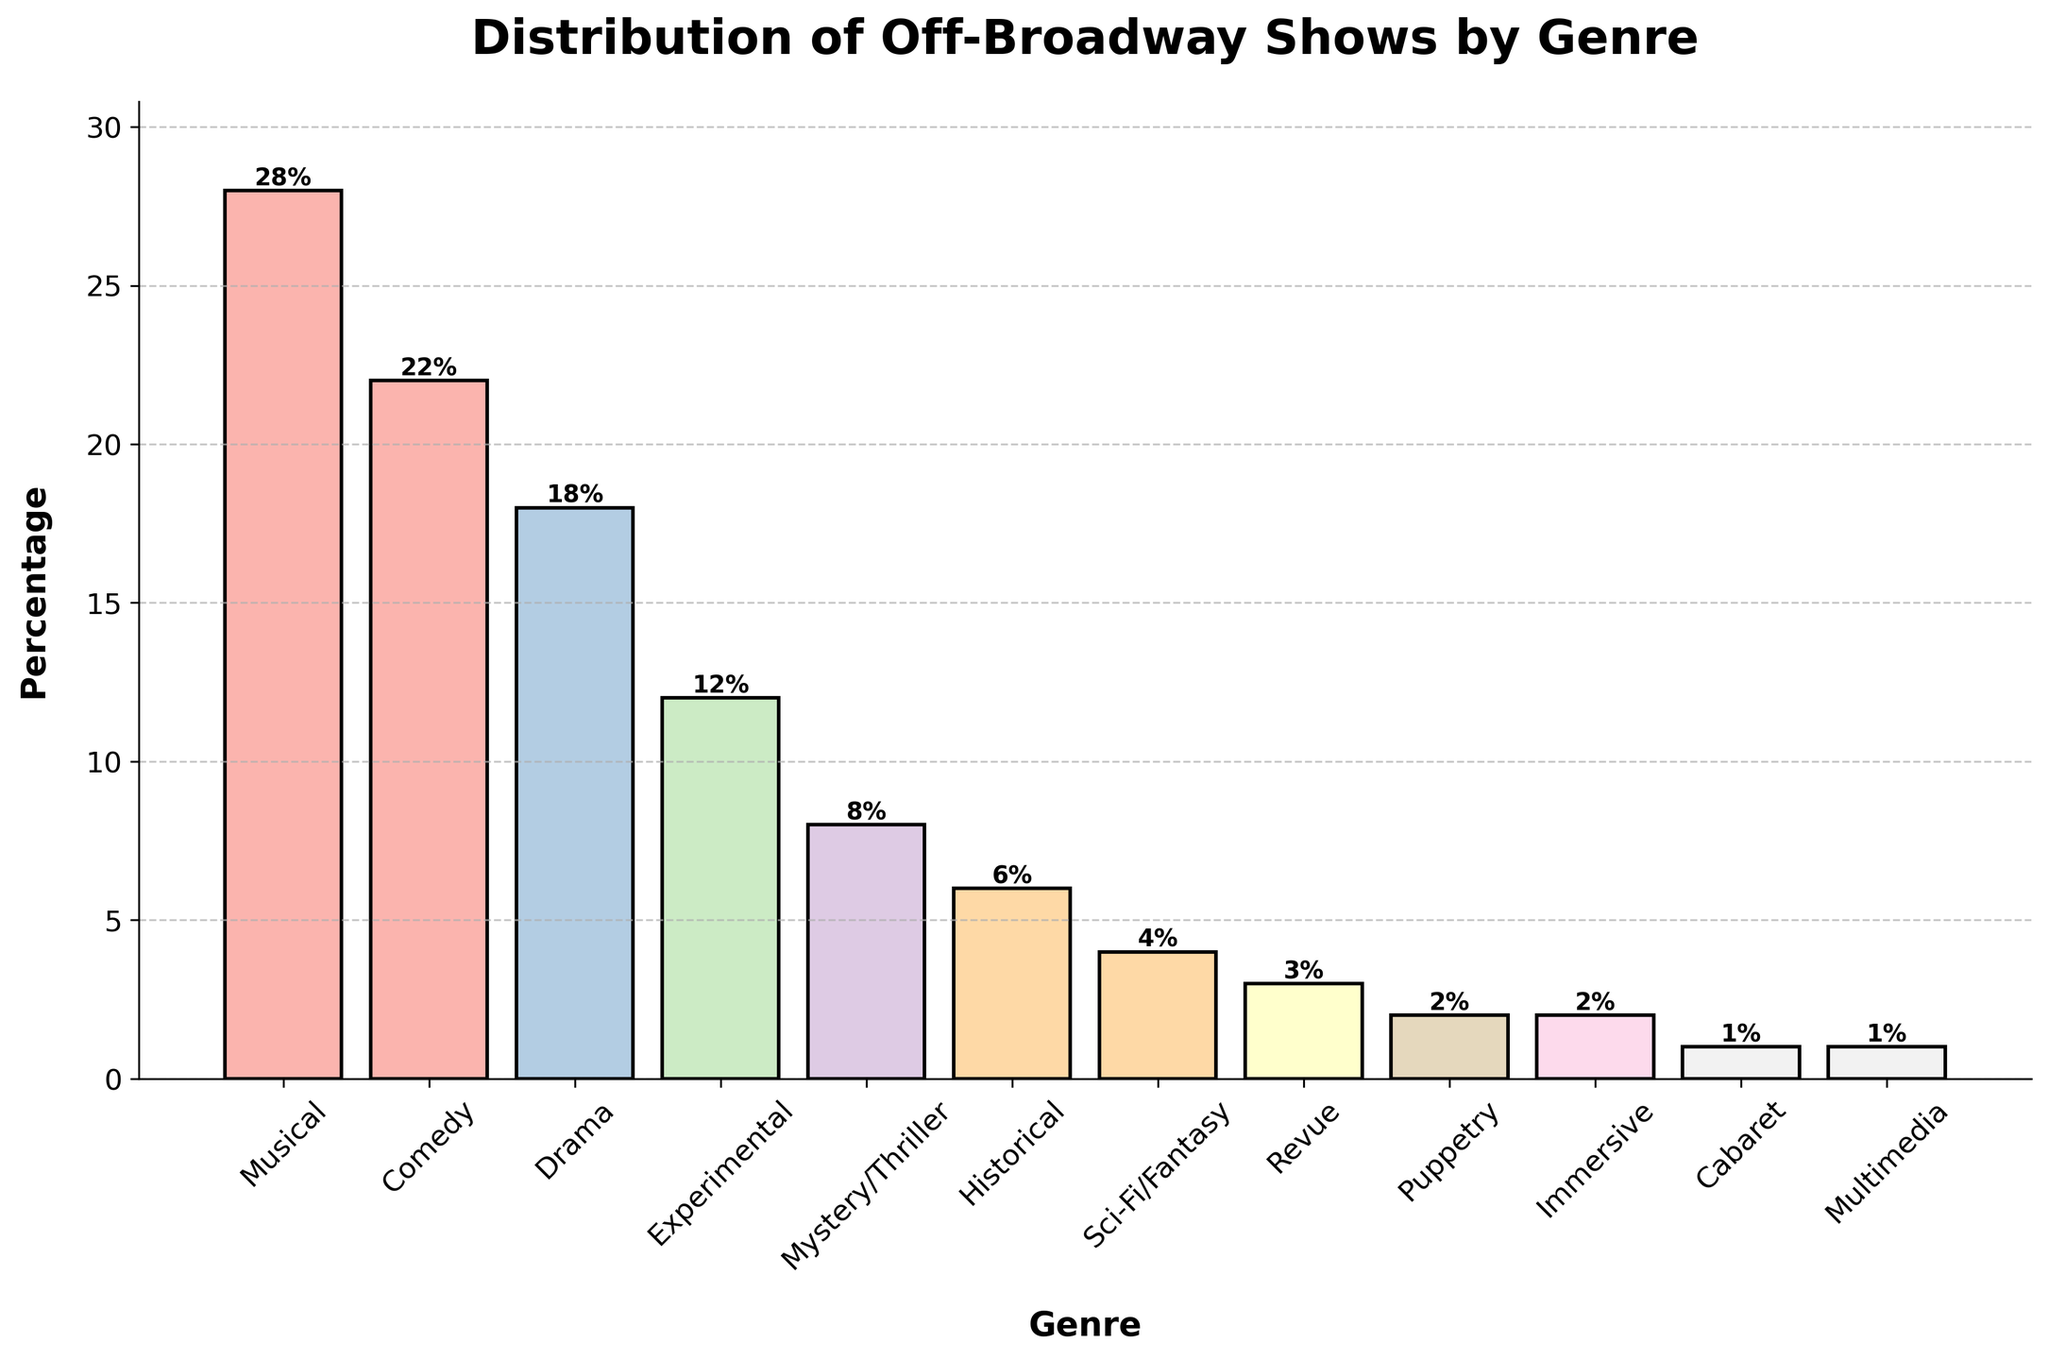What is the most common genre of off-Broadway shows in the last 5 years? By looking at the height of the bars, the tallest bar represents the genre with the highest percentage. The bar labeled "Musical" is the tallest.
Answer: Musical Which genre has a higher percentage, Comedy or Drama? By comparing the heights of the bars labeled "Comedy" and "Drama," the Comedy bar is taller.
Answer: Comedy What is the total percentage of off-Broadway shows that are either Experimental, Mystery/Thriller, or Historical? Summing the percentages of Experimental (12%), Mystery/Thriller (8%), and Historical (6%): 12% + 8% + 6% = 26%
Answer: 26% Is the percentage of Musical shows more than double the percentage of Comedy shows? The percentage of Musical shows is 28%, and the percentage of Comedy shows is 22%. Doubling the percentage of Comedy shows gives 22% * 2 = 44%. Since 28% < 44%, Musical shows are not more than double the percentage of Comedy shows.
Answer: No What is the second least common genre of off-Broadway shows? By observing the heights of the bars, the second smallest bar corresponds to the genre "Immersive" with 2%.
Answer: Immersive How does the percentage of Sci-Fi/Fantasy shows compare to the percentage of Revue shows? By examining the heights of the corresponding bars, Sci-Fi/Fantasy has a percentage of 4%, while Revue has a percentage of 3%. Sci-Fi/Fantasy has a higher percentage than Revue.
Answer: Sci-Fi/Fantasy What is the combined percentage of the three least common genres? Adding the percentages of Puppetry (2%), Immersive (2%), and Cabaret/Multimedia (both 1%): 2% + 2% + 1% + 1% = 6%
Answer: 6% Which genre is represented by the bar colored in the lightest shade? The lightest shade corresponds to the smallest percentage. The bar for Cabaret (1%) and Multimedia (1%) share this attribute.
Answer: Cabaret/Multimedia 